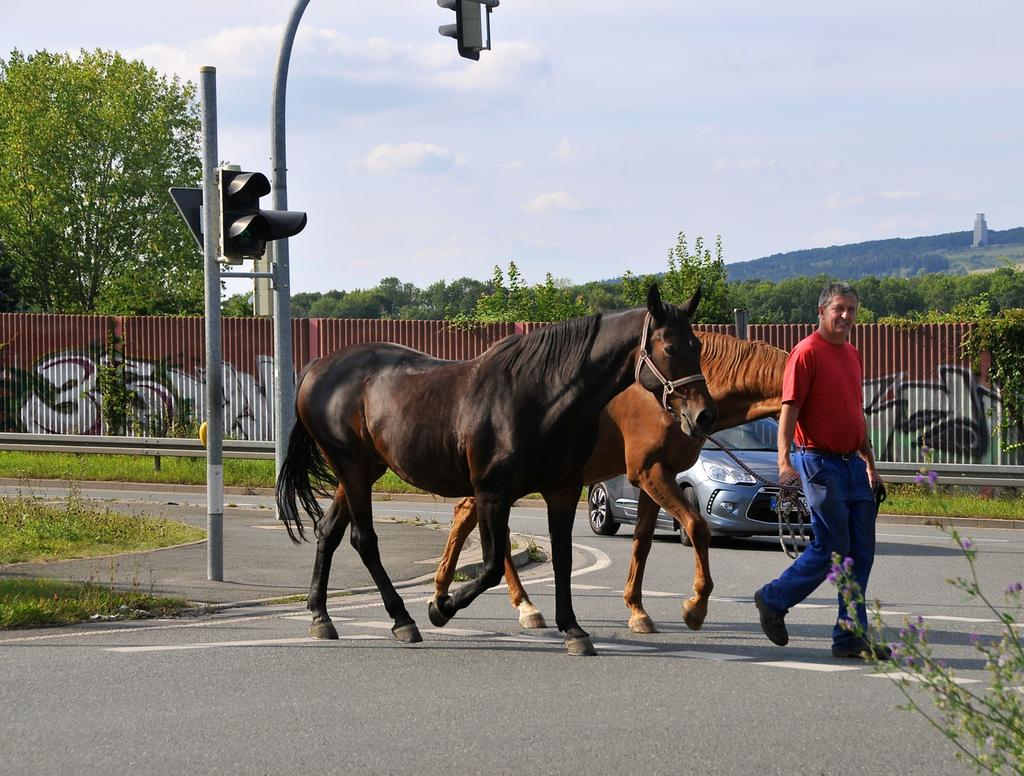What is happening in the image? There is a person in the image who is crossing the road. What is the person holding in the image? The person is holding two horses. What can be seen in the background of the image? There is a car, fencing, and trees in the background of the image. What type of wool is being used to create the mind-reading device in the image? There is no wool or mind-reading device present in the image. What type of celery can be seen growing in the background of the image? There is no celery present in the image; the background features a car, fencing, and trees. 